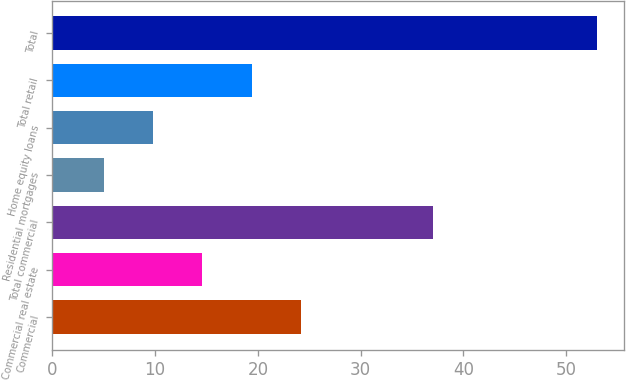Convert chart. <chart><loc_0><loc_0><loc_500><loc_500><bar_chart><fcel>Commercial<fcel>Commercial real estate<fcel>Total commercial<fcel>Residential mortgages<fcel>Home equity loans<fcel>Total retail<fcel>Total<nl><fcel>24.2<fcel>14.6<fcel>37<fcel>5<fcel>9.8<fcel>19.4<fcel>53<nl></chart> 